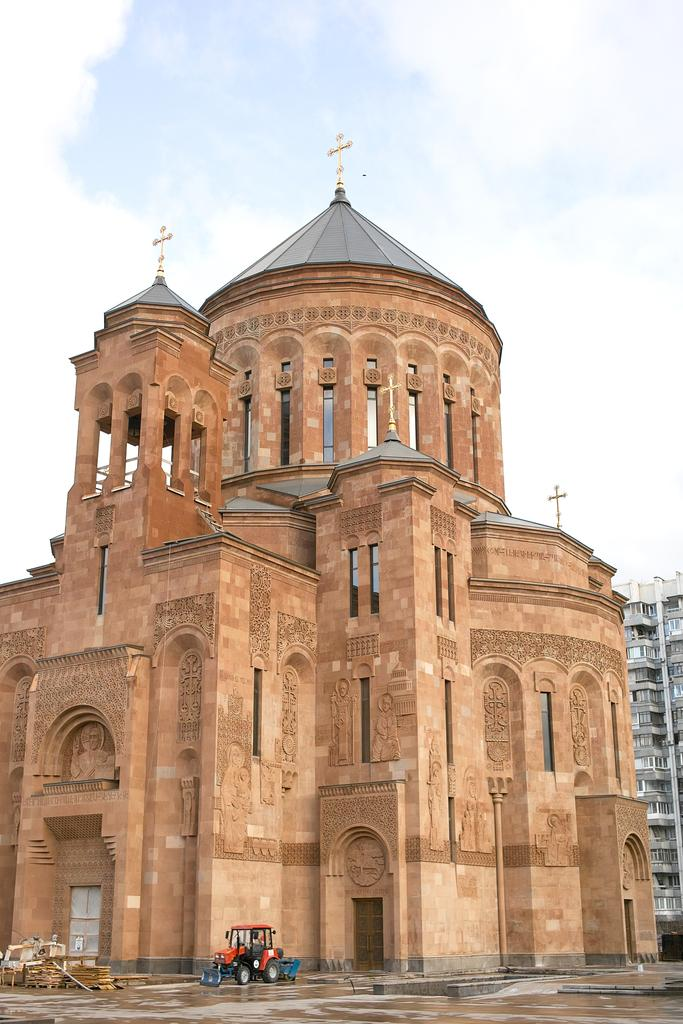What type of structures are present in the image? There are buildings with walls and windows in the image. What can be seen on a raised platform in the image? There is a vehicle on a platform in the image. What is visible in the background of the image? The sky is visible in the background of the image. What religious symbols are present in the image? There are holy crosses in the image. How much fuel is needed to power the library in the image? There is no library present in the image, so it is not possible to determine the fuel requirements for a library. 